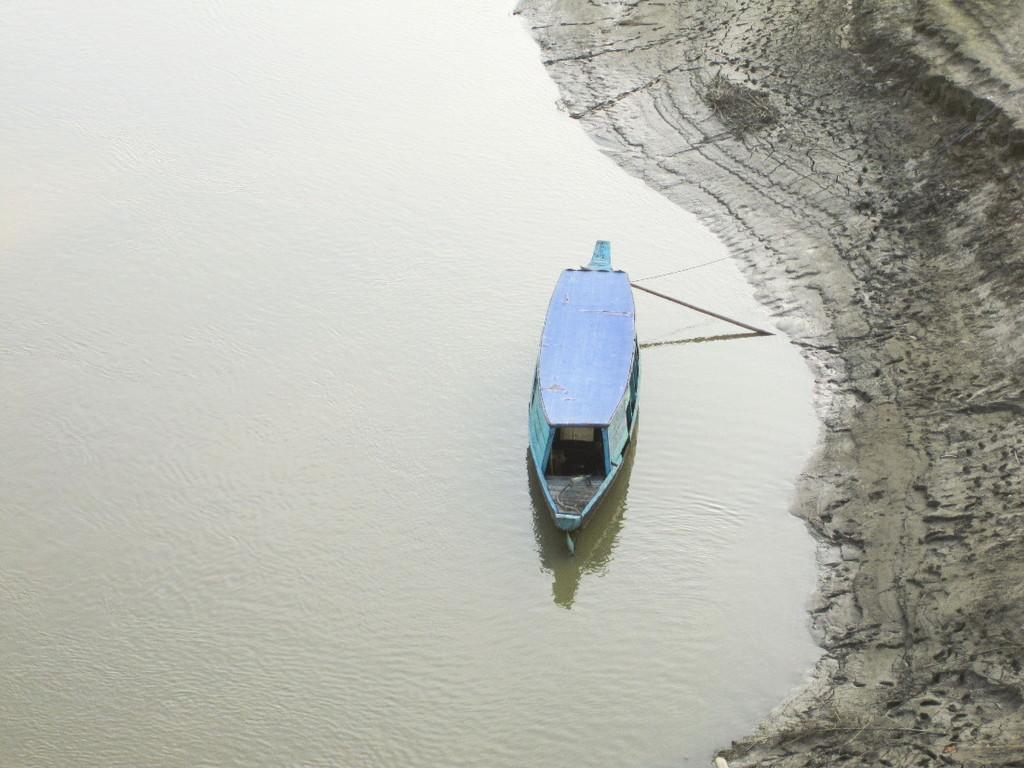Please provide a concise description of this image. In this image we can see a boat in the water, it is in blue color, here is the mud. 